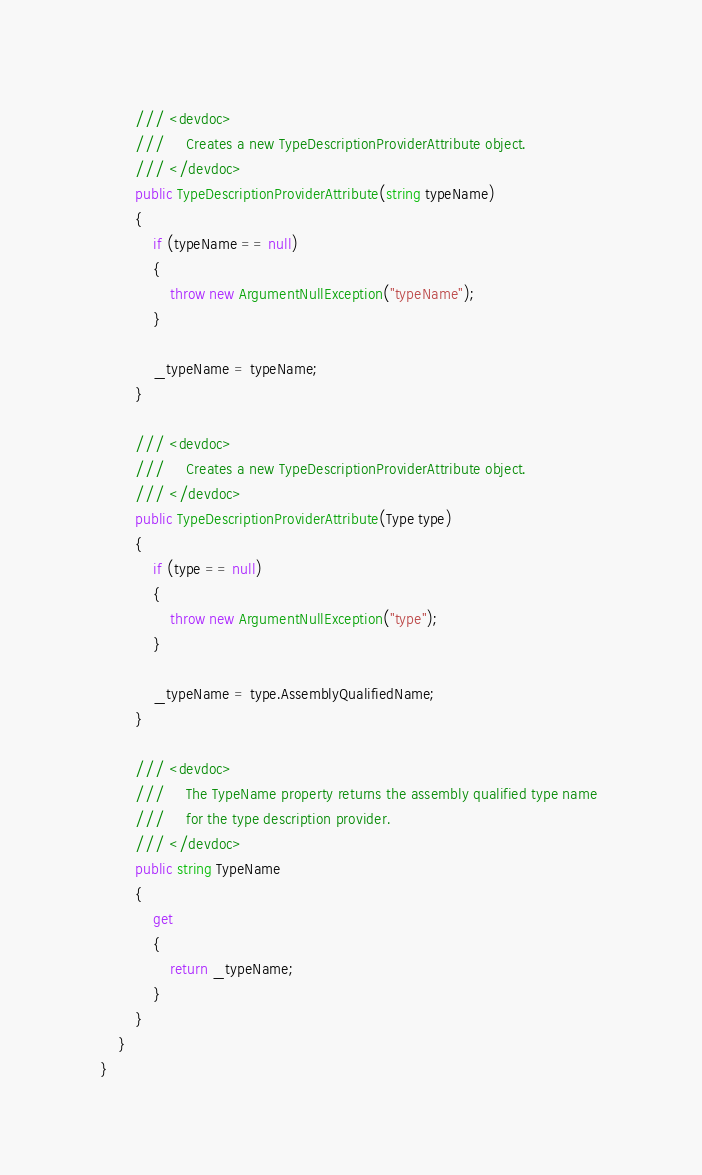Convert code to text. <code><loc_0><loc_0><loc_500><loc_500><_C#_>        /// <devdoc>
        ///     Creates a new TypeDescriptionProviderAttribute object.
        /// </devdoc>
        public TypeDescriptionProviderAttribute(string typeName)
        {
            if (typeName == null)
            {
                throw new ArgumentNullException("typeName");
            }

            _typeName = typeName;
        }
    
        /// <devdoc>
        ///     Creates a new TypeDescriptionProviderAttribute object.
        /// </devdoc>
        public TypeDescriptionProviderAttribute(Type type)
        {
            if (type == null)
            {
                throw new ArgumentNullException("type");
            }

            _typeName = type.AssemblyQualifiedName;
        }

        /// <devdoc>
        ///     The TypeName property returns the assembly qualified type name 
        ///     for the type description provider.
        /// </devdoc>
        public string TypeName
        {
            get
            {
                return _typeName;
            }
        }
    }
}

</code> 